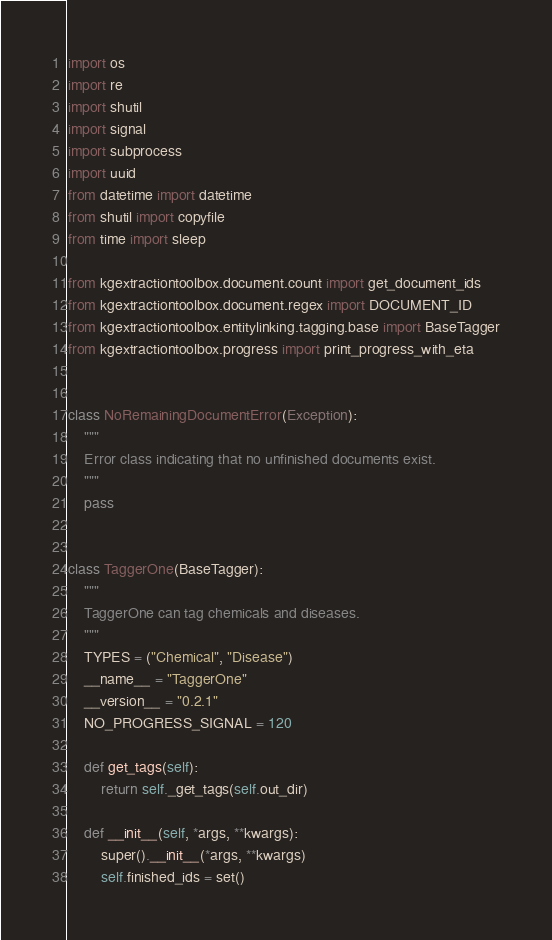Convert code to text. <code><loc_0><loc_0><loc_500><loc_500><_Python_>import os
import re
import shutil
import signal
import subprocess
import uuid
from datetime import datetime
from shutil import copyfile
from time import sleep

from kgextractiontoolbox.document.count import get_document_ids
from kgextractiontoolbox.document.regex import DOCUMENT_ID
from kgextractiontoolbox.entitylinking.tagging.base import BaseTagger
from kgextractiontoolbox.progress import print_progress_with_eta


class NoRemainingDocumentError(Exception):
    """
    Error class indicating that no unfinished documents exist.
    """
    pass


class TaggerOne(BaseTagger):
    """
    TaggerOne can tag chemicals and diseases.
    """
    TYPES = ("Chemical", "Disease")
    __name__ = "TaggerOne"
    __version__ = "0.2.1"
    NO_PROGRESS_SIGNAL = 120

    def get_tags(self):
        return self._get_tags(self.out_dir)

    def __init__(self, *args, **kwargs):
        super().__init__(*args, **kwargs)
        self.finished_ids = set()</code> 